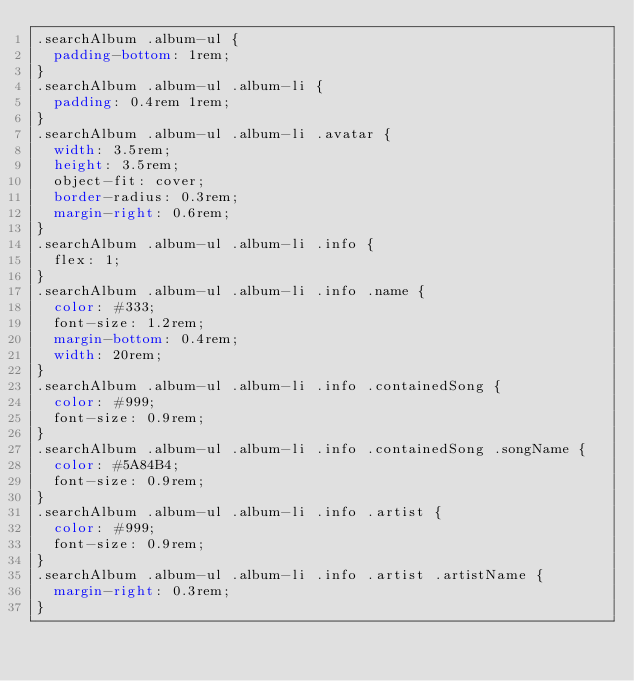Convert code to text. <code><loc_0><loc_0><loc_500><loc_500><_CSS_>.searchAlbum .album-ul {
  padding-bottom: 1rem;
}
.searchAlbum .album-ul .album-li {
  padding: 0.4rem 1rem;
}
.searchAlbum .album-ul .album-li .avatar {
  width: 3.5rem;
  height: 3.5rem;
  object-fit: cover;
  border-radius: 0.3rem;
  margin-right: 0.6rem;
}
.searchAlbum .album-ul .album-li .info {
  flex: 1;
}
.searchAlbum .album-ul .album-li .info .name {
  color: #333;
  font-size: 1.2rem;
  margin-bottom: 0.4rem;
  width: 20rem;
}
.searchAlbum .album-ul .album-li .info .containedSong {
  color: #999;
  font-size: 0.9rem;
}
.searchAlbum .album-ul .album-li .info .containedSong .songName {
  color: #5A84B4;
  font-size: 0.9rem;
}
.searchAlbum .album-ul .album-li .info .artist {
  color: #999;
  font-size: 0.9rem;
}
.searchAlbum .album-ul .album-li .info .artist .artistName {
  margin-right: 0.3rem;
}
</code> 